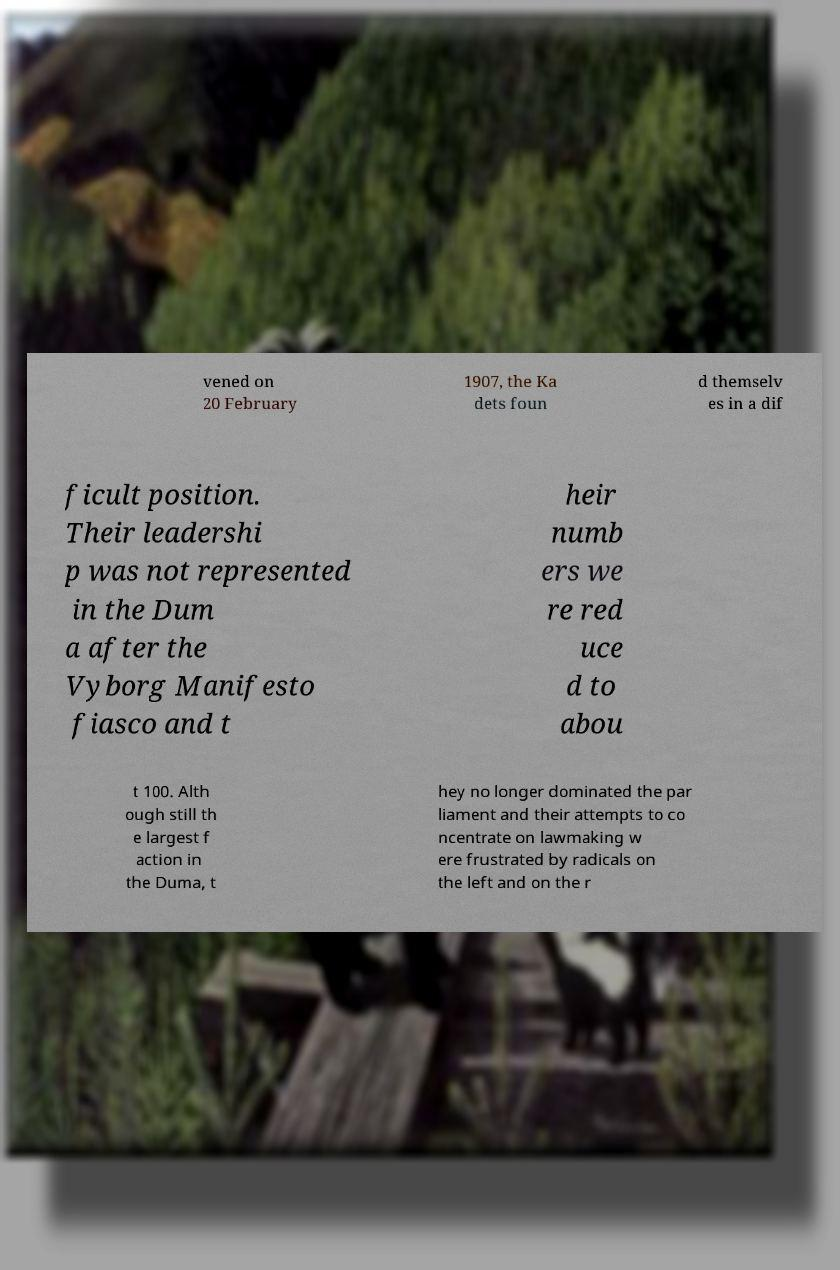Can you read and provide the text displayed in the image?This photo seems to have some interesting text. Can you extract and type it out for me? vened on 20 February 1907, the Ka dets foun d themselv es in a dif ficult position. Their leadershi p was not represented in the Dum a after the Vyborg Manifesto fiasco and t heir numb ers we re red uce d to abou t 100. Alth ough still th e largest f action in the Duma, t hey no longer dominated the par liament and their attempts to co ncentrate on lawmaking w ere frustrated by radicals on the left and on the r 